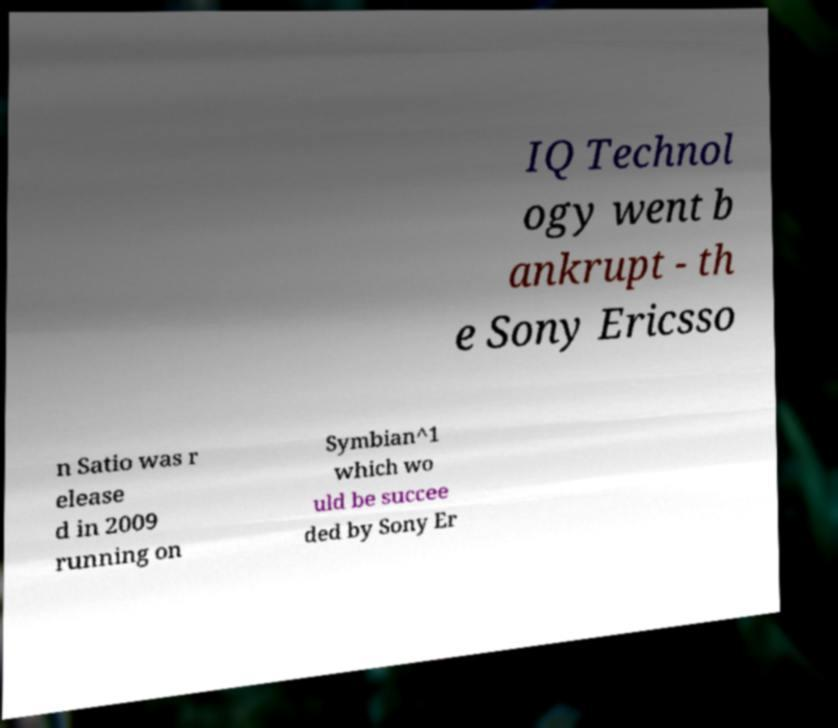Please identify and transcribe the text found in this image. IQ Technol ogy went b ankrupt - th e Sony Ericsso n Satio was r elease d in 2009 running on Symbian^1 which wo uld be succee ded by Sony Er 